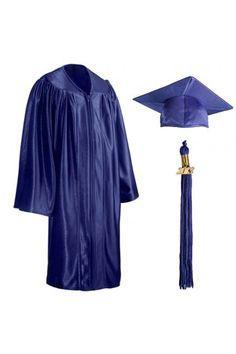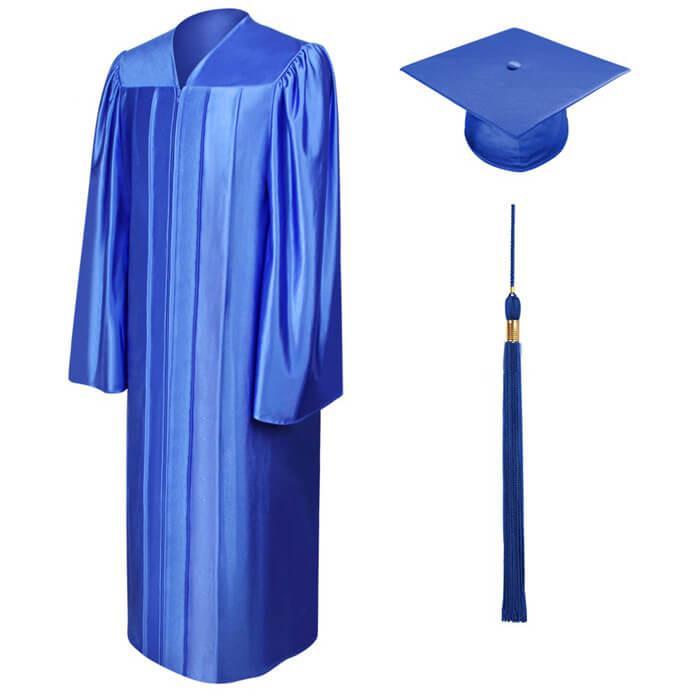The first image is the image on the left, the second image is the image on the right. For the images displayed, is the sentence "All of the graduation caps are blue." factually correct? Answer yes or no. Yes. The first image is the image on the left, the second image is the image on the right. For the images shown, is this caption "Both images contain red and blue." true? Answer yes or no. No. 